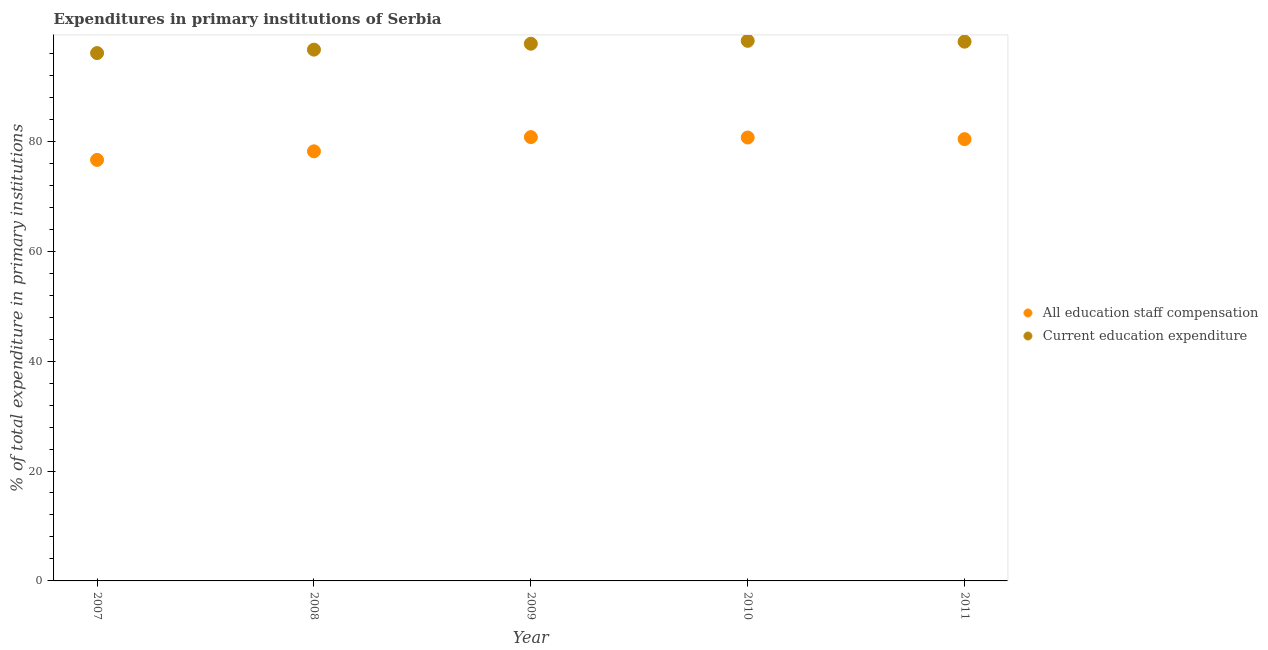Is the number of dotlines equal to the number of legend labels?
Your answer should be compact. Yes. What is the expenditure in staff compensation in 2011?
Make the answer very short. 80.39. Across all years, what is the maximum expenditure in staff compensation?
Make the answer very short. 80.76. Across all years, what is the minimum expenditure in staff compensation?
Provide a short and direct response. 76.61. In which year was the expenditure in staff compensation maximum?
Offer a very short reply. 2009. In which year was the expenditure in education minimum?
Your answer should be compact. 2007. What is the total expenditure in staff compensation in the graph?
Provide a short and direct response. 396.63. What is the difference between the expenditure in staff compensation in 2009 and that in 2011?
Your answer should be very brief. 0.37. What is the difference between the expenditure in education in 2011 and the expenditure in staff compensation in 2010?
Provide a short and direct response. 17.44. What is the average expenditure in staff compensation per year?
Ensure brevity in your answer.  79.33. In the year 2011, what is the difference between the expenditure in staff compensation and expenditure in education?
Give a very brief answer. -17.74. In how many years, is the expenditure in education greater than 36 %?
Your response must be concise. 5. What is the ratio of the expenditure in staff compensation in 2007 to that in 2011?
Offer a terse response. 0.95. Is the expenditure in staff compensation in 2008 less than that in 2009?
Provide a succinct answer. Yes. What is the difference between the highest and the second highest expenditure in education?
Make the answer very short. 0.15. What is the difference between the highest and the lowest expenditure in education?
Offer a terse response. 2.23. In how many years, is the expenditure in staff compensation greater than the average expenditure in staff compensation taken over all years?
Offer a terse response. 3. Does the expenditure in staff compensation monotonically increase over the years?
Make the answer very short. No. Is the expenditure in staff compensation strictly less than the expenditure in education over the years?
Offer a terse response. Yes. How many dotlines are there?
Your answer should be very brief. 2. Does the graph contain any zero values?
Provide a succinct answer. No. Where does the legend appear in the graph?
Offer a very short reply. Center right. How many legend labels are there?
Your answer should be compact. 2. How are the legend labels stacked?
Your answer should be very brief. Vertical. What is the title of the graph?
Give a very brief answer. Expenditures in primary institutions of Serbia. Does "Total Population" appear as one of the legend labels in the graph?
Your response must be concise. No. What is the label or title of the Y-axis?
Ensure brevity in your answer.  % of total expenditure in primary institutions. What is the % of total expenditure in primary institutions of All education staff compensation in 2007?
Your answer should be compact. 76.61. What is the % of total expenditure in primary institutions of Current education expenditure in 2007?
Your answer should be very brief. 96.05. What is the % of total expenditure in primary institutions of All education staff compensation in 2008?
Your answer should be very brief. 78.18. What is the % of total expenditure in primary institutions of Current education expenditure in 2008?
Ensure brevity in your answer.  96.68. What is the % of total expenditure in primary institutions of All education staff compensation in 2009?
Keep it short and to the point. 80.76. What is the % of total expenditure in primary institutions of Current education expenditure in 2009?
Provide a succinct answer. 97.76. What is the % of total expenditure in primary institutions in All education staff compensation in 2010?
Your answer should be compact. 80.69. What is the % of total expenditure in primary institutions of Current education expenditure in 2010?
Provide a succinct answer. 98.28. What is the % of total expenditure in primary institutions in All education staff compensation in 2011?
Offer a terse response. 80.39. What is the % of total expenditure in primary institutions of Current education expenditure in 2011?
Offer a very short reply. 98.13. Across all years, what is the maximum % of total expenditure in primary institutions of All education staff compensation?
Provide a succinct answer. 80.76. Across all years, what is the maximum % of total expenditure in primary institutions in Current education expenditure?
Offer a very short reply. 98.28. Across all years, what is the minimum % of total expenditure in primary institutions of All education staff compensation?
Provide a succinct answer. 76.61. Across all years, what is the minimum % of total expenditure in primary institutions of Current education expenditure?
Provide a succinct answer. 96.05. What is the total % of total expenditure in primary institutions of All education staff compensation in the graph?
Offer a very short reply. 396.63. What is the total % of total expenditure in primary institutions of Current education expenditure in the graph?
Keep it short and to the point. 486.9. What is the difference between the % of total expenditure in primary institutions of All education staff compensation in 2007 and that in 2008?
Offer a very short reply. -1.56. What is the difference between the % of total expenditure in primary institutions in Current education expenditure in 2007 and that in 2008?
Provide a succinct answer. -0.63. What is the difference between the % of total expenditure in primary institutions in All education staff compensation in 2007 and that in 2009?
Ensure brevity in your answer.  -4.15. What is the difference between the % of total expenditure in primary institutions of Current education expenditure in 2007 and that in 2009?
Provide a succinct answer. -1.7. What is the difference between the % of total expenditure in primary institutions of All education staff compensation in 2007 and that in 2010?
Your response must be concise. -4.07. What is the difference between the % of total expenditure in primary institutions of Current education expenditure in 2007 and that in 2010?
Ensure brevity in your answer.  -2.23. What is the difference between the % of total expenditure in primary institutions in All education staff compensation in 2007 and that in 2011?
Give a very brief answer. -3.78. What is the difference between the % of total expenditure in primary institutions of Current education expenditure in 2007 and that in 2011?
Give a very brief answer. -2.08. What is the difference between the % of total expenditure in primary institutions of All education staff compensation in 2008 and that in 2009?
Your response must be concise. -2.59. What is the difference between the % of total expenditure in primary institutions in Current education expenditure in 2008 and that in 2009?
Give a very brief answer. -1.08. What is the difference between the % of total expenditure in primary institutions of All education staff compensation in 2008 and that in 2010?
Give a very brief answer. -2.51. What is the difference between the % of total expenditure in primary institutions of Current education expenditure in 2008 and that in 2010?
Make the answer very short. -1.6. What is the difference between the % of total expenditure in primary institutions in All education staff compensation in 2008 and that in 2011?
Your answer should be very brief. -2.22. What is the difference between the % of total expenditure in primary institutions in Current education expenditure in 2008 and that in 2011?
Ensure brevity in your answer.  -1.45. What is the difference between the % of total expenditure in primary institutions of All education staff compensation in 2009 and that in 2010?
Provide a short and direct response. 0.08. What is the difference between the % of total expenditure in primary institutions of Current education expenditure in 2009 and that in 2010?
Ensure brevity in your answer.  -0.53. What is the difference between the % of total expenditure in primary institutions in All education staff compensation in 2009 and that in 2011?
Ensure brevity in your answer.  0.37. What is the difference between the % of total expenditure in primary institutions of Current education expenditure in 2009 and that in 2011?
Give a very brief answer. -0.37. What is the difference between the % of total expenditure in primary institutions of All education staff compensation in 2010 and that in 2011?
Offer a very short reply. 0.29. What is the difference between the % of total expenditure in primary institutions in Current education expenditure in 2010 and that in 2011?
Your answer should be very brief. 0.15. What is the difference between the % of total expenditure in primary institutions in All education staff compensation in 2007 and the % of total expenditure in primary institutions in Current education expenditure in 2008?
Ensure brevity in your answer.  -20.07. What is the difference between the % of total expenditure in primary institutions of All education staff compensation in 2007 and the % of total expenditure in primary institutions of Current education expenditure in 2009?
Give a very brief answer. -21.14. What is the difference between the % of total expenditure in primary institutions in All education staff compensation in 2007 and the % of total expenditure in primary institutions in Current education expenditure in 2010?
Your response must be concise. -21.67. What is the difference between the % of total expenditure in primary institutions in All education staff compensation in 2007 and the % of total expenditure in primary institutions in Current education expenditure in 2011?
Your answer should be compact. -21.52. What is the difference between the % of total expenditure in primary institutions in All education staff compensation in 2008 and the % of total expenditure in primary institutions in Current education expenditure in 2009?
Your answer should be very brief. -19.58. What is the difference between the % of total expenditure in primary institutions in All education staff compensation in 2008 and the % of total expenditure in primary institutions in Current education expenditure in 2010?
Your response must be concise. -20.11. What is the difference between the % of total expenditure in primary institutions of All education staff compensation in 2008 and the % of total expenditure in primary institutions of Current education expenditure in 2011?
Your answer should be compact. -19.95. What is the difference between the % of total expenditure in primary institutions of All education staff compensation in 2009 and the % of total expenditure in primary institutions of Current education expenditure in 2010?
Your answer should be compact. -17.52. What is the difference between the % of total expenditure in primary institutions of All education staff compensation in 2009 and the % of total expenditure in primary institutions of Current education expenditure in 2011?
Offer a terse response. -17.37. What is the difference between the % of total expenditure in primary institutions of All education staff compensation in 2010 and the % of total expenditure in primary institutions of Current education expenditure in 2011?
Provide a succinct answer. -17.44. What is the average % of total expenditure in primary institutions in All education staff compensation per year?
Provide a succinct answer. 79.33. What is the average % of total expenditure in primary institutions in Current education expenditure per year?
Give a very brief answer. 97.38. In the year 2007, what is the difference between the % of total expenditure in primary institutions in All education staff compensation and % of total expenditure in primary institutions in Current education expenditure?
Give a very brief answer. -19.44. In the year 2008, what is the difference between the % of total expenditure in primary institutions in All education staff compensation and % of total expenditure in primary institutions in Current education expenditure?
Your answer should be very brief. -18.5. In the year 2009, what is the difference between the % of total expenditure in primary institutions in All education staff compensation and % of total expenditure in primary institutions in Current education expenditure?
Offer a terse response. -16.99. In the year 2010, what is the difference between the % of total expenditure in primary institutions of All education staff compensation and % of total expenditure in primary institutions of Current education expenditure?
Make the answer very short. -17.6. In the year 2011, what is the difference between the % of total expenditure in primary institutions of All education staff compensation and % of total expenditure in primary institutions of Current education expenditure?
Give a very brief answer. -17.74. What is the ratio of the % of total expenditure in primary institutions in Current education expenditure in 2007 to that in 2008?
Offer a very short reply. 0.99. What is the ratio of the % of total expenditure in primary institutions in All education staff compensation in 2007 to that in 2009?
Give a very brief answer. 0.95. What is the ratio of the % of total expenditure in primary institutions of Current education expenditure in 2007 to that in 2009?
Your response must be concise. 0.98. What is the ratio of the % of total expenditure in primary institutions of All education staff compensation in 2007 to that in 2010?
Offer a terse response. 0.95. What is the ratio of the % of total expenditure in primary institutions of Current education expenditure in 2007 to that in 2010?
Ensure brevity in your answer.  0.98. What is the ratio of the % of total expenditure in primary institutions in All education staff compensation in 2007 to that in 2011?
Offer a very short reply. 0.95. What is the ratio of the % of total expenditure in primary institutions of Current education expenditure in 2007 to that in 2011?
Your answer should be very brief. 0.98. What is the ratio of the % of total expenditure in primary institutions in All education staff compensation in 2008 to that in 2010?
Your answer should be very brief. 0.97. What is the ratio of the % of total expenditure in primary institutions of Current education expenditure in 2008 to that in 2010?
Ensure brevity in your answer.  0.98. What is the ratio of the % of total expenditure in primary institutions of All education staff compensation in 2008 to that in 2011?
Provide a succinct answer. 0.97. What is the ratio of the % of total expenditure in primary institutions of Current education expenditure in 2008 to that in 2011?
Give a very brief answer. 0.99. What is the ratio of the % of total expenditure in primary institutions of All education staff compensation in 2009 to that in 2010?
Offer a very short reply. 1. What is the ratio of the % of total expenditure in primary institutions in Current education expenditure in 2009 to that in 2010?
Give a very brief answer. 0.99. What is the ratio of the % of total expenditure in primary institutions in Current education expenditure in 2009 to that in 2011?
Make the answer very short. 1. What is the ratio of the % of total expenditure in primary institutions in All education staff compensation in 2010 to that in 2011?
Your response must be concise. 1. What is the ratio of the % of total expenditure in primary institutions in Current education expenditure in 2010 to that in 2011?
Your answer should be very brief. 1. What is the difference between the highest and the second highest % of total expenditure in primary institutions of All education staff compensation?
Offer a very short reply. 0.08. What is the difference between the highest and the second highest % of total expenditure in primary institutions of Current education expenditure?
Give a very brief answer. 0.15. What is the difference between the highest and the lowest % of total expenditure in primary institutions in All education staff compensation?
Offer a very short reply. 4.15. What is the difference between the highest and the lowest % of total expenditure in primary institutions of Current education expenditure?
Ensure brevity in your answer.  2.23. 